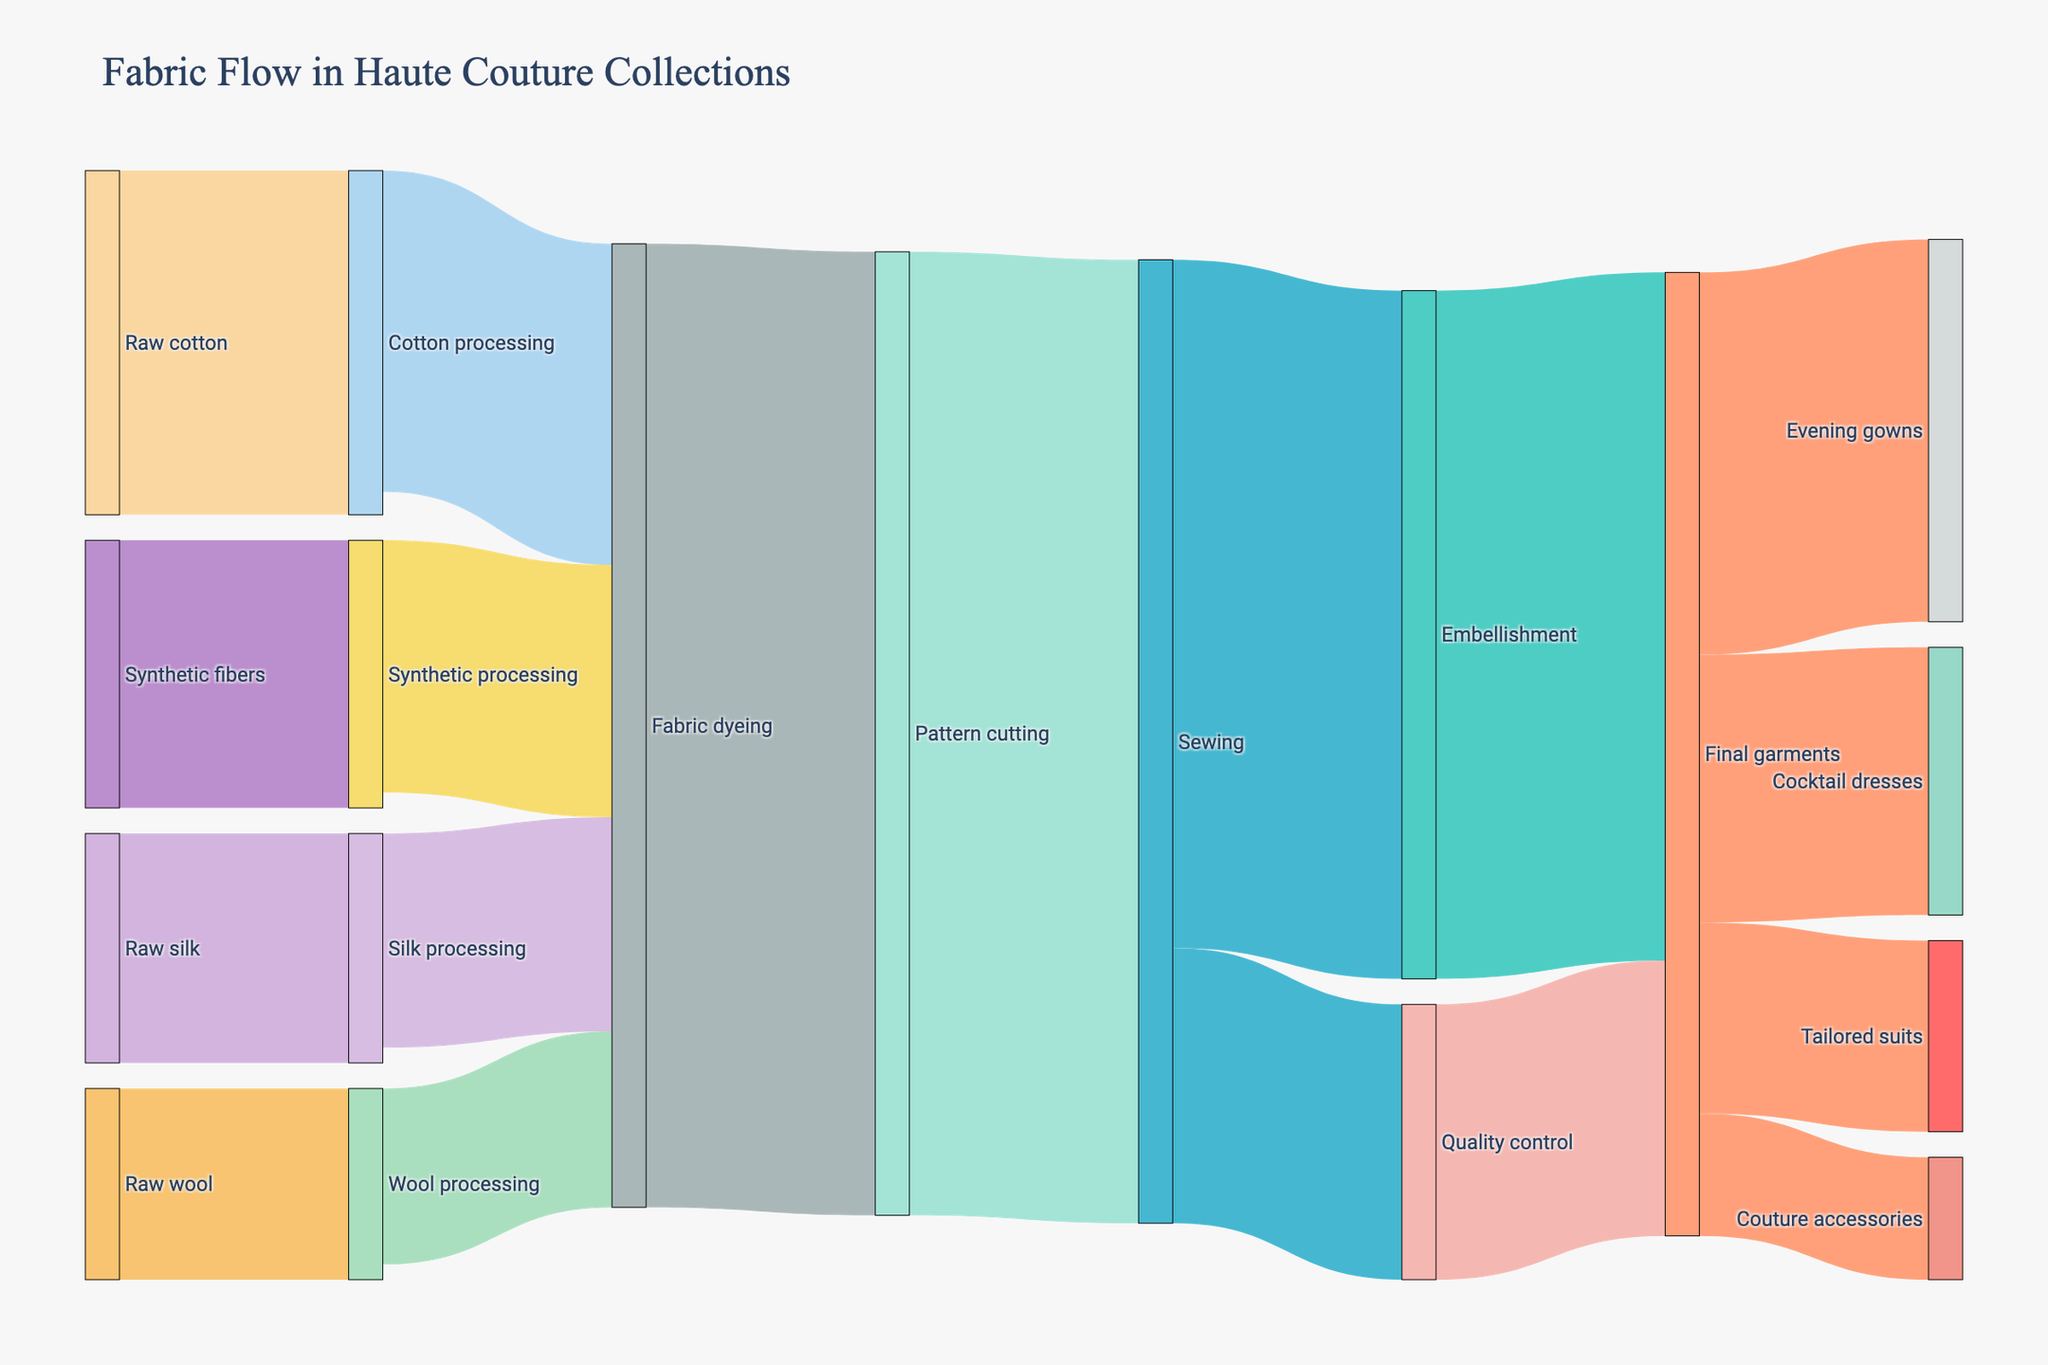what is the title of the diagram? The title of the diagram is located at the top of the figure, presented prominently.
Answer: Fabric Flow in Haute Couture Collections How many labels are used in the Sankey diagram? We observe that unique labels represent different stages in the process. Counting them from the figure gives a total of 15 labels.
Answer: 15 Which stage receives the most raw material in terms of value? By examining the size of the colored flows entering each initial processing stage, 'Cotton processing' is the largest. Summing up values for each initial stage confirms this.
Answer: Cotton processing Add up the total value from 'Fabric dyeing' to 'Pattern cutting'. Identify the link(s) from 'Fabric dyeing' to 'Pattern cutting' and add the value of each link. This gives a total of 12600.
Answer: 12600 Compare the final garment categories by value. Which one has the smallest value? Comparing the widths of the flows going to 'Evening gowns', 'Cocktail dresses', 'Tailored suits', and 'Couture accessories', the narrowest flow is to 'Couture accessories'.
Answer: Couture accessories What is the value of the flow from 'Sewing' to 'Embellishment'? By looking at the flow from 'Sewing' to 'Embellishment' in the diagram, we see that it is labeled with a value of 9000.
Answer: 9000 Sum the values of final garments. Add up the values flowing into 'Final garments' categories: 5000 + 3500 + 2500 + 1600 totals to 12600.
Answer: 12600 From which stage does the 'Quality control' receive its flow? The flow to 'Quality control' originates directly from 'Sewing'. The diagram shows this with a link between them.
Answer: Sewing What is the sum of values flowing out of 'Pattern cutting'? The 'Pattern cutting' stage sends its flow to 'Sewing', and the value of that flow is 12600.
Answer: 12600 Which segment has the highest value among raw materials? By observing the flows entering the processing stages, 'Raw cotton' with 4500 is the largest in terms of value.
Answer: Raw cotton 